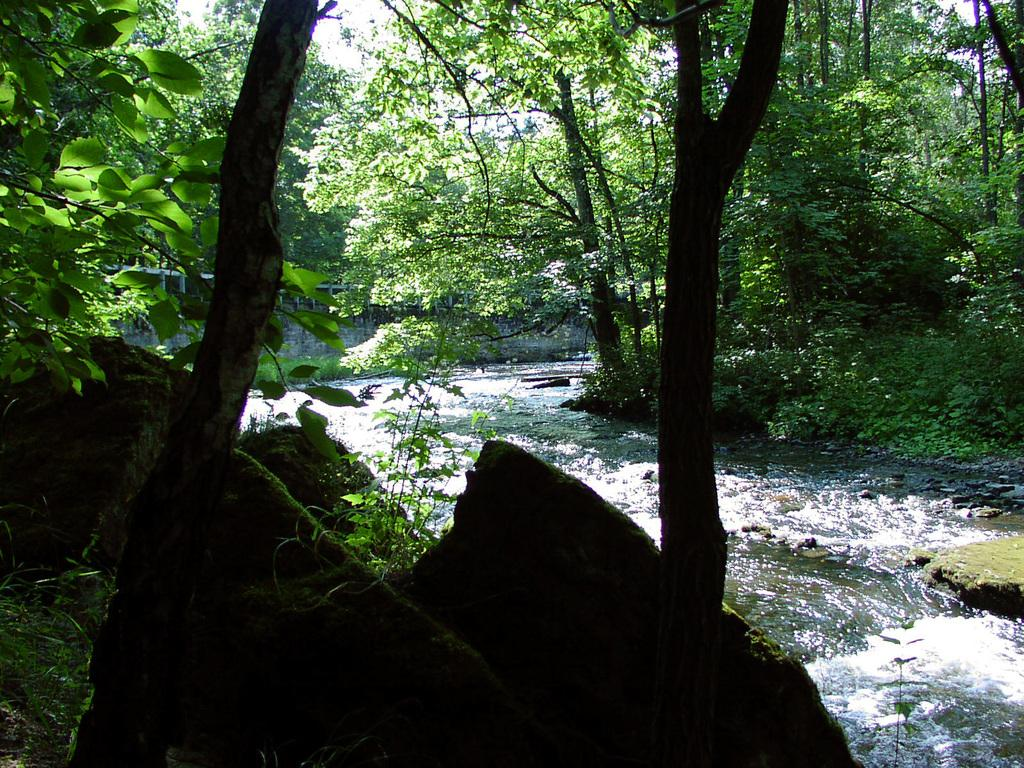What type of vegetation can be seen in the image? There are trees in the image. What other natural elements are present in the image? There are stones and a river in the image. How many baskets can be seen hanging from the trees in the image? There are no baskets present in the image. What level of difficulty is associated with the river in the image? The image does not provide information about the difficulty level of the river. 